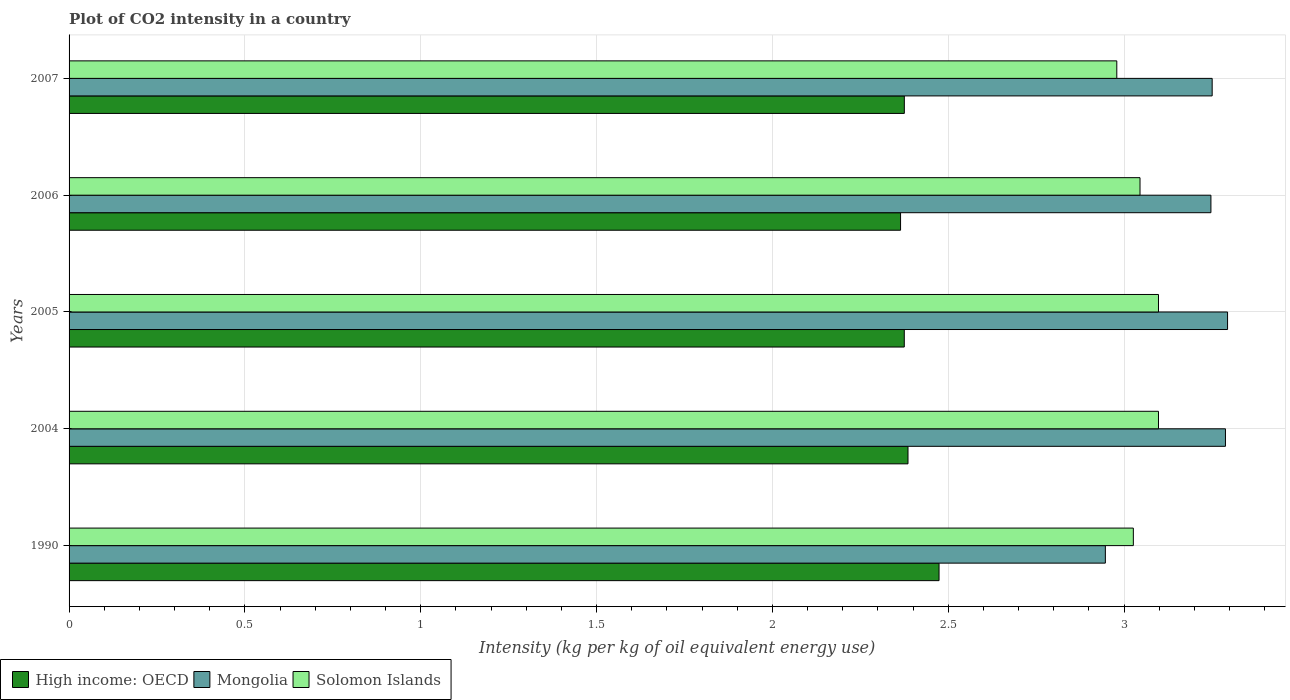How many groups of bars are there?
Offer a very short reply. 5. Are the number of bars per tick equal to the number of legend labels?
Your answer should be very brief. Yes. How many bars are there on the 2nd tick from the top?
Provide a short and direct response. 3. How many bars are there on the 4th tick from the bottom?
Make the answer very short. 3. What is the label of the 3rd group of bars from the top?
Provide a succinct answer. 2005. In how many cases, is the number of bars for a given year not equal to the number of legend labels?
Keep it short and to the point. 0. What is the CO2 intensity in in Mongolia in 1990?
Provide a short and direct response. 2.95. Across all years, what is the maximum CO2 intensity in in High income: OECD?
Your answer should be compact. 2.47. Across all years, what is the minimum CO2 intensity in in High income: OECD?
Provide a short and direct response. 2.36. In which year was the CO2 intensity in in Solomon Islands maximum?
Offer a very short reply. 2004. What is the total CO2 intensity in in Mongolia in the graph?
Make the answer very short. 16.03. What is the difference between the CO2 intensity in in High income: OECD in 2005 and that in 2006?
Keep it short and to the point. 0.01. What is the difference between the CO2 intensity in in Solomon Islands in 1990 and the CO2 intensity in in High income: OECD in 2005?
Keep it short and to the point. 0.65. What is the average CO2 intensity in in Mongolia per year?
Your answer should be very brief. 3.21. In the year 2005, what is the difference between the CO2 intensity in in Solomon Islands and CO2 intensity in in Mongolia?
Offer a terse response. -0.2. In how many years, is the CO2 intensity in in Solomon Islands greater than 1.4 kg?
Give a very brief answer. 5. What is the ratio of the CO2 intensity in in High income: OECD in 2004 to that in 2006?
Make the answer very short. 1.01. Is the difference between the CO2 intensity in in Solomon Islands in 2004 and 2007 greater than the difference between the CO2 intensity in in Mongolia in 2004 and 2007?
Make the answer very short. Yes. What is the difference between the highest and the second highest CO2 intensity in in Mongolia?
Ensure brevity in your answer.  0.01. What is the difference between the highest and the lowest CO2 intensity in in High income: OECD?
Provide a succinct answer. 0.11. Is the sum of the CO2 intensity in in Mongolia in 2005 and 2007 greater than the maximum CO2 intensity in in High income: OECD across all years?
Make the answer very short. Yes. What does the 3rd bar from the top in 2007 represents?
Provide a succinct answer. High income: OECD. What does the 3rd bar from the bottom in 2004 represents?
Your answer should be compact. Solomon Islands. What is the difference between two consecutive major ticks on the X-axis?
Offer a terse response. 0.5. Are the values on the major ticks of X-axis written in scientific E-notation?
Offer a very short reply. No. Does the graph contain grids?
Your answer should be compact. Yes. Where does the legend appear in the graph?
Make the answer very short. Bottom left. How are the legend labels stacked?
Provide a short and direct response. Horizontal. What is the title of the graph?
Give a very brief answer. Plot of CO2 intensity in a country. What is the label or title of the X-axis?
Your response must be concise. Intensity (kg per kg of oil equivalent energy use). What is the Intensity (kg per kg of oil equivalent energy use) in High income: OECD in 1990?
Your answer should be very brief. 2.47. What is the Intensity (kg per kg of oil equivalent energy use) in Mongolia in 1990?
Offer a very short reply. 2.95. What is the Intensity (kg per kg of oil equivalent energy use) of Solomon Islands in 1990?
Offer a terse response. 3.03. What is the Intensity (kg per kg of oil equivalent energy use) of High income: OECD in 2004?
Offer a terse response. 2.39. What is the Intensity (kg per kg of oil equivalent energy use) of Mongolia in 2004?
Ensure brevity in your answer.  3.29. What is the Intensity (kg per kg of oil equivalent energy use) in Solomon Islands in 2004?
Your answer should be very brief. 3.1. What is the Intensity (kg per kg of oil equivalent energy use) of High income: OECD in 2005?
Provide a succinct answer. 2.38. What is the Intensity (kg per kg of oil equivalent energy use) of Mongolia in 2005?
Your answer should be compact. 3.29. What is the Intensity (kg per kg of oil equivalent energy use) in Solomon Islands in 2005?
Provide a succinct answer. 3.1. What is the Intensity (kg per kg of oil equivalent energy use) of High income: OECD in 2006?
Offer a very short reply. 2.36. What is the Intensity (kg per kg of oil equivalent energy use) in Mongolia in 2006?
Provide a short and direct response. 3.25. What is the Intensity (kg per kg of oil equivalent energy use) of Solomon Islands in 2006?
Your answer should be compact. 3.05. What is the Intensity (kg per kg of oil equivalent energy use) of High income: OECD in 2007?
Offer a terse response. 2.38. What is the Intensity (kg per kg of oil equivalent energy use) in Mongolia in 2007?
Offer a terse response. 3.25. What is the Intensity (kg per kg of oil equivalent energy use) in Solomon Islands in 2007?
Your response must be concise. 2.98. Across all years, what is the maximum Intensity (kg per kg of oil equivalent energy use) of High income: OECD?
Your response must be concise. 2.47. Across all years, what is the maximum Intensity (kg per kg of oil equivalent energy use) in Mongolia?
Your answer should be compact. 3.29. Across all years, what is the maximum Intensity (kg per kg of oil equivalent energy use) in Solomon Islands?
Provide a succinct answer. 3.1. Across all years, what is the minimum Intensity (kg per kg of oil equivalent energy use) in High income: OECD?
Give a very brief answer. 2.36. Across all years, what is the minimum Intensity (kg per kg of oil equivalent energy use) of Mongolia?
Your answer should be compact. 2.95. Across all years, what is the minimum Intensity (kg per kg of oil equivalent energy use) in Solomon Islands?
Provide a short and direct response. 2.98. What is the total Intensity (kg per kg of oil equivalent energy use) in High income: OECD in the graph?
Offer a terse response. 11.97. What is the total Intensity (kg per kg of oil equivalent energy use) in Mongolia in the graph?
Keep it short and to the point. 16.03. What is the total Intensity (kg per kg of oil equivalent energy use) of Solomon Islands in the graph?
Provide a succinct answer. 15.25. What is the difference between the Intensity (kg per kg of oil equivalent energy use) in High income: OECD in 1990 and that in 2004?
Give a very brief answer. 0.09. What is the difference between the Intensity (kg per kg of oil equivalent energy use) of Mongolia in 1990 and that in 2004?
Your answer should be very brief. -0.34. What is the difference between the Intensity (kg per kg of oil equivalent energy use) of Solomon Islands in 1990 and that in 2004?
Provide a succinct answer. -0.07. What is the difference between the Intensity (kg per kg of oil equivalent energy use) in High income: OECD in 1990 and that in 2005?
Provide a succinct answer. 0.1. What is the difference between the Intensity (kg per kg of oil equivalent energy use) in Mongolia in 1990 and that in 2005?
Provide a succinct answer. -0.35. What is the difference between the Intensity (kg per kg of oil equivalent energy use) in Solomon Islands in 1990 and that in 2005?
Give a very brief answer. -0.07. What is the difference between the Intensity (kg per kg of oil equivalent energy use) in High income: OECD in 1990 and that in 2006?
Provide a succinct answer. 0.11. What is the difference between the Intensity (kg per kg of oil equivalent energy use) in Mongolia in 1990 and that in 2006?
Offer a terse response. -0.3. What is the difference between the Intensity (kg per kg of oil equivalent energy use) of Solomon Islands in 1990 and that in 2006?
Give a very brief answer. -0.02. What is the difference between the Intensity (kg per kg of oil equivalent energy use) of High income: OECD in 1990 and that in 2007?
Your answer should be compact. 0.1. What is the difference between the Intensity (kg per kg of oil equivalent energy use) in Mongolia in 1990 and that in 2007?
Provide a succinct answer. -0.3. What is the difference between the Intensity (kg per kg of oil equivalent energy use) in Solomon Islands in 1990 and that in 2007?
Give a very brief answer. 0.05. What is the difference between the Intensity (kg per kg of oil equivalent energy use) of High income: OECD in 2004 and that in 2005?
Keep it short and to the point. 0.01. What is the difference between the Intensity (kg per kg of oil equivalent energy use) of Mongolia in 2004 and that in 2005?
Provide a short and direct response. -0.01. What is the difference between the Intensity (kg per kg of oil equivalent energy use) in High income: OECD in 2004 and that in 2006?
Ensure brevity in your answer.  0.02. What is the difference between the Intensity (kg per kg of oil equivalent energy use) of Mongolia in 2004 and that in 2006?
Your response must be concise. 0.04. What is the difference between the Intensity (kg per kg of oil equivalent energy use) of Solomon Islands in 2004 and that in 2006?
Your answer should be compact. 0.05. What is the difference between the Intensity (kg per kg of oil equivalent energy use) of High income: OECD in 2004 and that in 2007?
Your response must be concise. 0.01. What is the difference between the Intensity (kg per kg of oil equivalent energy use) of Mongolia in 2004 and that in 2007?
Provide a succinct answer. 0.04. What is the difference between the Intensity (kg per kg of oil equivalent energy use) of Solomon Islands in 2004 and that in 2007?
Your answer should be very brief. 0.12. What is the difference between the Intensity (kg per kg of oil equivalent energy use) of High income: OECD in 2005 and that in 2006?
Ensure brevity in your answer.  0.01. What is the difference between the Intensity (kg per kg of oil equivalent energy use) of Mongolia in 2005 and that in 2006?
Your answer should be compact. 0.05. What is the difference between the Intensity (kg per kg of oil equivalent energy use) of Solomon Islands in 2005 and that in 2006?
Keep it short and to the point. 0.05. What is the difference between the Intensity (kg per kg of oil equivalent energy use) in High income: OECD in 2005 and that in 2007?
Offer a very short reply. -0. What is the difference between the Intensity (kg per kg of oil equivalent energy use) in Mongolia in 2005 and that in 2007?
Your answer should be very brief. 0.04. What is the difference between the Intensity (kg per kg of oil equivalent energy use) in Solomon Islands in 2005 and that in 2007?
Make the answer very short. 0.12. What is the difference between the Intensity (kg per kg of oil equivalent energy use) in High income: OECD in 2006 and that in 2007?
Keep it short and to the point. -0.01. What is the difference between the Intensity (kg per kg of oil equivalent energy use) of Mongolia in 2006 and that in 2007?
Offer a very short reply. -0. What is the difference between the Intensity (kg per kg of oil equivalent energy use) in Solomon Islands in 2006 and that in 2007?
Ensure brevity in your answer.  0.07. What is the difference between the Intensity (kg per kg of oil equivalent energy use) of High income: OECD in 1990 and the Intensity (kg per kg of oil equivalent energy use) of Mongolia in 2004?
Keep it short and to the point. -0.81. What is the difference between the Intensity (kg per kg of oil equivalent energy use) of High income: OECD in 1990 and the Intensity (kg per kg of oil equivalent energy use) of Solomon Islands in 2004?
Provide a succinct answer. -0.62. What is the difference between the Intensity (kg per kg of oil equivalent energy use) of Mongolia in 1990 and the Intensity (kg per kg of oil equivalent energy use) of Solomon Islands in 2004?
Ensure brevity in your answer.  -0.15. What is the difference between the Intensity (kg per kg of oil equivalent energy use) of High income: OECD in 1990 and the Intensity (kg per kg of oil equivalent energy use) of Mongolia in 2005?
Ensure brevity in your answer.  -0.82. What is the difference between the Intensity (kg per kg of oil equivalent energy use) of High income: OECD in 1990 and the Intensity (kg per kg of oil equivalent energy use) of Solomon Islands in 2005?
Give a very brief answer. -0.62. What is the difference between the Intensity (kg per kg of oil equivalent energy use) in Mongolia in 1990 and the Intensity (kg per kg of oil equivalent energy use) in Solomon Islands in 2005?
Your answer should be compact. -0.15. What is the difference between the Intensity (kg per kg of oil equivalent energy use) in High income: OECD in 1990 and the Intensity (kg per kg of oil equivalent energy use) in Mongolia in 2006?
Your answer should be very brief. -0.77. What is the difference between the Intensity (kg per kg of oil equivalent energy use) of High income: OECD in 1990 and the Intensity (kg per kg of oil equivalent energy use) of Solomon Islands in 2006?
Offer a very short reply. -0.57. What is the difference between the Intensity (kg per kg of oil equivalent energy use) in Mongolia in 1990 and the Intensity (kg per kg of oil equivalent energy use) in Solomon Islands in 2006?
Give a very brief answer. -0.1. What is the difference between the Intensity (kg per kg of oil equivalent energy use) in High income: OECD in 1990 and the Intensity (kg per kg of oil equivalent energy use) in Mongolia in 2007?
Keep it short and to the point. -0.78. What is the difference between the Intensity (kg per kg of oil equivalent energy use) in High income: OECD in 1990 and the Intensity (kg per kg of oil equivalent energy use) in Solomon Islands in 2007?
Your response must be concise. -0.51. What is the difference between the Intensity (kg per kg of oil equivalent energy use) in Mongolia in 1990 and the Intensity (kg per kg of oil equivalent energy use) in Solomon Islands in 2007?
Your response must be concise. -0.03. What is the difference between the Intensity (kg per kg of oil equivalent energy use) of High income: OECD in 2004 and the Intensity (kg per kg of oil equivalent energy use) of Mongolia in 2005?
Offer a very short reply. -0.91. What is the difference between the Intensity (kg per kg of oil equivalent energy use) of High income: OECD in 2004 and the Intensity (kg per kg of oil equivalent energy use) of Solomon Islands in 2005?
Your answer should be compact. -0.71. What is the difference between the Intensity (kg per kg of oil equivalent energy use) of Mongolia in 2004 and the Intensity (kg per kg of oil equivalent energy use) of Solomon Islands in 2005?
Make the answer very short. 0.19. What is the difference between the Intensity (kg per kg of oil equivalent energy use) of High income: OECD in 2004 and the Intensity (kg per kg of oil equivalent energy use) of Mongolia in 2006?
Keep it short and to the point. -0.86. What is the difference between the Intensity (kg per kg of oil equivalent energy use) of High income: OECD in 2004 and the Intensity (kg per kg of oil equivalent energy use) of Solomon Islands in 2006?
Keep it short and to the point. -0.66. What is the difference between the Intensity (kg per kg of oil equivalent energy use) of Mongolia in 2004 and the Intensity (kg per kg of oil equivalent energy use) of Solomon Islands in 2006?
Keep it short and to the point. 0.24. What is the difference between the Intensity (kg per kg of oil equivalent energy use) of High income: OECD in 2004 and the Intensity (kg per kg of oil equivalent energy use) of Mongolia in 2007?
Ensure brevity in your answer.  -0.86. What is the difference between the Intensity (kg per kg of oil equivalent energy use) in High income: OECD in 2004 and the Intensity (kg per kg of oil equivalent energy use) in Solomon Islands in 2007?
Offer a very short reply. -0.59. What is the difference between the Intensity (kg per kg of oil equivalent energy use) in Mongolia in 2004 and the Intensity (kg per kg of oil equivalent energy use) in Solomon Islands in 2007?
Offer a very short reply. 0.31. What is the difference between the Intensity (kg per kg of oil equivalent energy use) in High income: OECD in 2005 and the Intensity (kg per kg of oil equivalent energy use) in Mongolia in 2006?
Provide a short and direct response. -0.87. What is the difference between the Intensity (kg per kg of oil equivalent energy use) of High income: OECD in 2005 and the Intensity (kg per kg of oil equivalent energy use) of Solomon Islands in 2006?
Offer a terse response. -0.67. What is the difference between the Intensity (kg per kg of oil equivalent energy use) in Mongolia in 2005 and the Intensity (kg per kg of oil equivalent energy use) in Solomon Islands in 2006?
Provide a succinct answer. 0.25. What is the difference between the Intensity (kg per kg of oil equivalent energy use) in High income: OECD in 2005 and the Intensity (kg per kg of oil equivalent energy use) in Mongolia in 2007?
Provide a succinct answer. -0.88. What is the difference between the Intensity (kg per kg of oil equivalent energy use) in High income: OECD in 2005 and the Intensity (kg per kg of oil equivalent energy use) in Solomon Islands in 2007?
Your response must be concise. -0.6. What is the difference between the Intensity (kg per kg of oil equivalent energy use) of Mongolia in 2005 and the Intensity (kg per kg of oil equivalent energy use) of Solomon Islands in 2007?
Make the answer very short. 0.32. What is the difference between the Intensity (kg per kg of oil equivalent energy use) of High income: OECD in 2006 and the Intensity (kg per kg of oil equivalent energy use) of Mongolia in 2007?
Ensure brevity in your answer.  -0.89. What is the difference between the Intensity (kg per kg of oil equivalent energy use) in High income: OECD in 2006 and the Intensity (kg per kg of oil equivalent energy use) in Solomon Islands in 2007?
Provide a succinct answer. -0.61. What is the difference between the Intensity (kg per kg of oil equivalent energy use) in Mongolia in 2006 and the Intensity (kg per kg of oil equivalent energy use) in Solomon Islands in 2007?
Offer a terse response. 0.27. What is the average Intensity (kg per kg of oil equivalent energy use) in High income: OECD per year?
Keep it short and to the point. 2.39. What is the average Intensity (kg per kg of oil equivalent energy use) of Mongolia per year?
Offer a very short reply. 3.21. What is the average Intensity (kg per kg of oil equivalent energy use) of Solomon Islands per year?
Give a very brief answer. 3.05. In the year 1990, what is the difference between the Intensity (kg per kg of oil equivalent energy use) in High income: OECD and Intensity (kg per kg of oil equivalent energy use) in Mongolia?
Provide a short and direct response. -0.47. In the year 1990, what is the difference between the Intensity (kg per kg of oil equivalent energy use) of High income: OECD and Intensity (kg per kg of oil equivalent energy use) of Solomon Islands?
Your answer should be compact. -0.55. In the year 1990, what is the difference between the Intensity (kg per kg of oil equivalent energy use) of Mongolia and Intensity (kg per kg of oil equivalent energy use) of Solomon Islands?
Offer a terse response. -0.08. In the year 2004, what is the difference between the Intensity (kg per kg of oil equivalent energy use) of High income: OECD and Intensity (kg per kg of oil equivalent energy use) of Mongolia?
Offer a very short reply. -0.9. In the year 2004, what is the difference between the Intensity (kg per kg of oil equivalent energy use) in High income: OECD and Intensity (kg per kg of oil equivalent energy use) in Solomon Islands?
Your answer should be very brief. -0.71. In the year 2004, what is the difference between the Intensity (kg per kg of oil equivalent energy use) of Mongolia and Intensity (kg per kg of oil equivalent energy use) of Solomon Islands?
Provide a succinct answer. 0.19. In the year 2005, what is the difference between the Intensity (kg per kg of oil equivalent energy use) in High income: OECD and Intensity (kg per kg of oil equivalent energy use) in Mongolia?
Offer a terse response. -0.92. In the year 2005, what is the difference between the Intensity (kg per kg of oil equivalent energy use) of High income: OECD and Intensity (kg per kg of oil equivalent energy use) of Solomon Islands?
Ensure brevity in your answer.  -0.72. In the year 2005, what is the difference between the Intensity (kg per kg of oil equivalent energy use) in Mongolia and Intensity (kg per kg of oil equivalent energy use) in Solomon Islands?
Keep it short and to the point. 0.2. In the year 2006, what is the difference between the Intensity (kg per kg of oil equivalent energy use) of High income: OECD and Intensity (kg per kg of oil equivalent energy use) of Mongolia?
Ensure brevity in your answer.  -0.88. In the year 2006, what is the difference between the Intensity (kg per kg of oil equivalent energy use) of High income: OECD and Intensity (kg per kg of oil equivalent energy use) of Solomon Islands?
Keep it short and to the point. -0.68. In the year 2006, what is the difference between the Intensity (kg per kg of oil equivalent energy use) in Mongolia and Intensity (kg per kg of oil equivalent energy use) in Solomon Islands?
Keep it short and to the point. 0.2. In the year 2007, what is the difference between the Intensity (kg per kg of oil equivalent energy use) in High income: OECD and Intensity (kg per kg of oil equivalent energy use) in Mongolia?
Ensure brevity in your answer.  -0.88. In the year 2007, what is the difference between the Intensity (kg per kg of oil equivalent energy use) in High income: OECD and Intensity (kg per kg of oil equivalent energy use) in Solomon Islands?
Give a very brief answer. -0.6. In the year 2007, what is the difference between the Intensity (kg per kg of oil equivalent energy use) in Mongolia and Intensity (kg per kg of oil equivalent energy use) in Solomon Islands?
Provide a short and direct response. 0.27. What is the ratio of the Intensity (kg per kg of oil equivalent energy use) of Mongolia in 1990 to that in 2004?
Give a very brief answer. 0.9. What is the ratio of the Intensity (kg per kg of oil equivalent energy use) of Solomon Islands in 1990 to that in 2004?
Your answer should be very brief. 0.98. What is the ratio of the Intensity (kg per kg of oil equivalent energy use) of High income: OECD in 1990 to that in 2005?
Ensure brevity in your answer.  1.04. What is the ratio of the Intensity (kg per kg of oil equivalent energy use) of Mongolia in 1990 to that in 2005?
Provide a short and direct response. 0.89. What is the ratio of the Intensity (kg per kg of oil equivalent energy use) of Solomon Islands in 1990 to that in 2005?
Provide a succinct answer. 0.98. What is the ratio of the Intensity (kg per kg of oil equivalent energy use) of High income: OECD in 1990 to that in 2006?
Provide a short and direct response. 1.05. What is the ratio of the Intensity (kg per kg of oil equivalent energy use) in Mongolia in 1990 to that in 2006?
Make the answer very short. 0.91. What is the ratio of the Intensity (kg per kg of oil equivalent energy use) in Solomon Islands in 1990 to that in 2006?
Your answer should be compact. 0.99. What is the ratio of the Intensity (kg per kg of oil equivalent energy use) of High income: OECD in 1990 to that in 2007?
Give a very brief answer. 1.04. What is the ratio of the Intensity (kg per kg of oil equivalent energy use) of Mongolia in 1990 to that in 2007?
Your response must be concise. 0.91. What is the ratio of the Intensity (kg per kg of oil equivalent energy use) of Solomon Islands in 1990 to that in 2007?
Give a very brief answer. 1.02. What is the ratio of the Intensity (kg per kg of oil equivalent energy use) of Mongolia in 2004 to that in 2005?
Give a very brief answer. 1. What is the ratio of the Intensity (kg per kg of oil equivalent energy use) of High income: OECD in 2004 to that in 2006?
Ensure brevity in your answer.  1.01. What is the ratio of the Intensity (kg per kg of oil equivalent energy use) of Mongolia in 2004 to that in 2006?
Your response must be concise. 1.01. What is the ratio of the Intensity (kg per kg of oil equivalent energy use) in Solomon Islands in 2004 to that in 2006?
Give a very brief answer. 1.02. What is the ratio of the Intensity (kg per kg of oil equivalent energy use) of High income: OECD in 2004 to that in 2007?
Offer a very short reply. 1. What is the ratio of the Intensity (kg per kg of oil equivalent energy use) in Mongolia in 2004 to that in 2007?
Offer a very short reply. 1.01. What is the ratio of the Intensity (kg per kg of oil equivalent energy use) in Solomon Islands in 2004 to that in 2007?
Ensure brevity in your answer.  1.04. What is the ratio of the Intensity (kg per kg of oil equivalent energy use) of High income: OECD in 2005 to that in 2006?
Offer a very short reply. 1. What is the ratio of the Intensity (kg per kg of oil equivalent energy use) in Mongolia in 2005 to that in 2006?
Your answer should be very brief. 1.01. What is the ratio of the Intensity (kg per kg of oil equivalent energy use) of Solomon Islands in 2005 to that in 2006?
Offer a very short reply. 1.02. What is the ratio of the Intensity (kg per kg of oil equivalent energy use) in High income: OECD in 2005 to that in 2007?
Give a very brief answer. 1. What is the ratio of the Intensity (kg per kg of oil equivalent energy use) of Mongolia in 2005 to that in 2007?
Provide a short and direct response. 1.01. What is the ratio of the Intensity (kg per kg of oil equivalent energy use) in Solomon Islands in 2005 to that in 2007?
Make the answer very short. 1.04. What is the ratio of the Intensity (kg per kg of oil equivalent energy use) in High income: OECD in 2006 to that in 2007?
Your answer should be compact. 1. What is the ratio of the Intensity (kg per kg of oil equivalent energy use) in Mongolia in 2006 to that in 2007?
Offer a very short reply. 1. What is the ratio of the Intensity (kg per kg of oil equivalent energy use) in Solomon Islands in 2006 to that in 2007?
Provide a short and direct response. 1.02. What is the difference between the highest and the second highest Intensity (kg per kg of oil equivalent energy use) of High income: OECD?
Make the answer very short. 0.09. What is the difference between the highest and the second highest Intensity (kg per kg of oil equivalent energy use) in Mongolia?
Give a very brief answer. 0.01. What is the difference between the highest and the lowest Intensity (kg per kg of oil equivalent energy use) of High income: OECD?
Offer a very short reply. 0.11. What is the difference between the highest and the lowest Intensity (kg per kg of oil equivalent energy use) in Mongolia?
Your answer should be very brief. 0.35. What is the difference between the highest and the lowest Intensity (kg per kg of oil equivalent energy use) of Solomon Islands?
Keep it short and to the point. 0.12. 